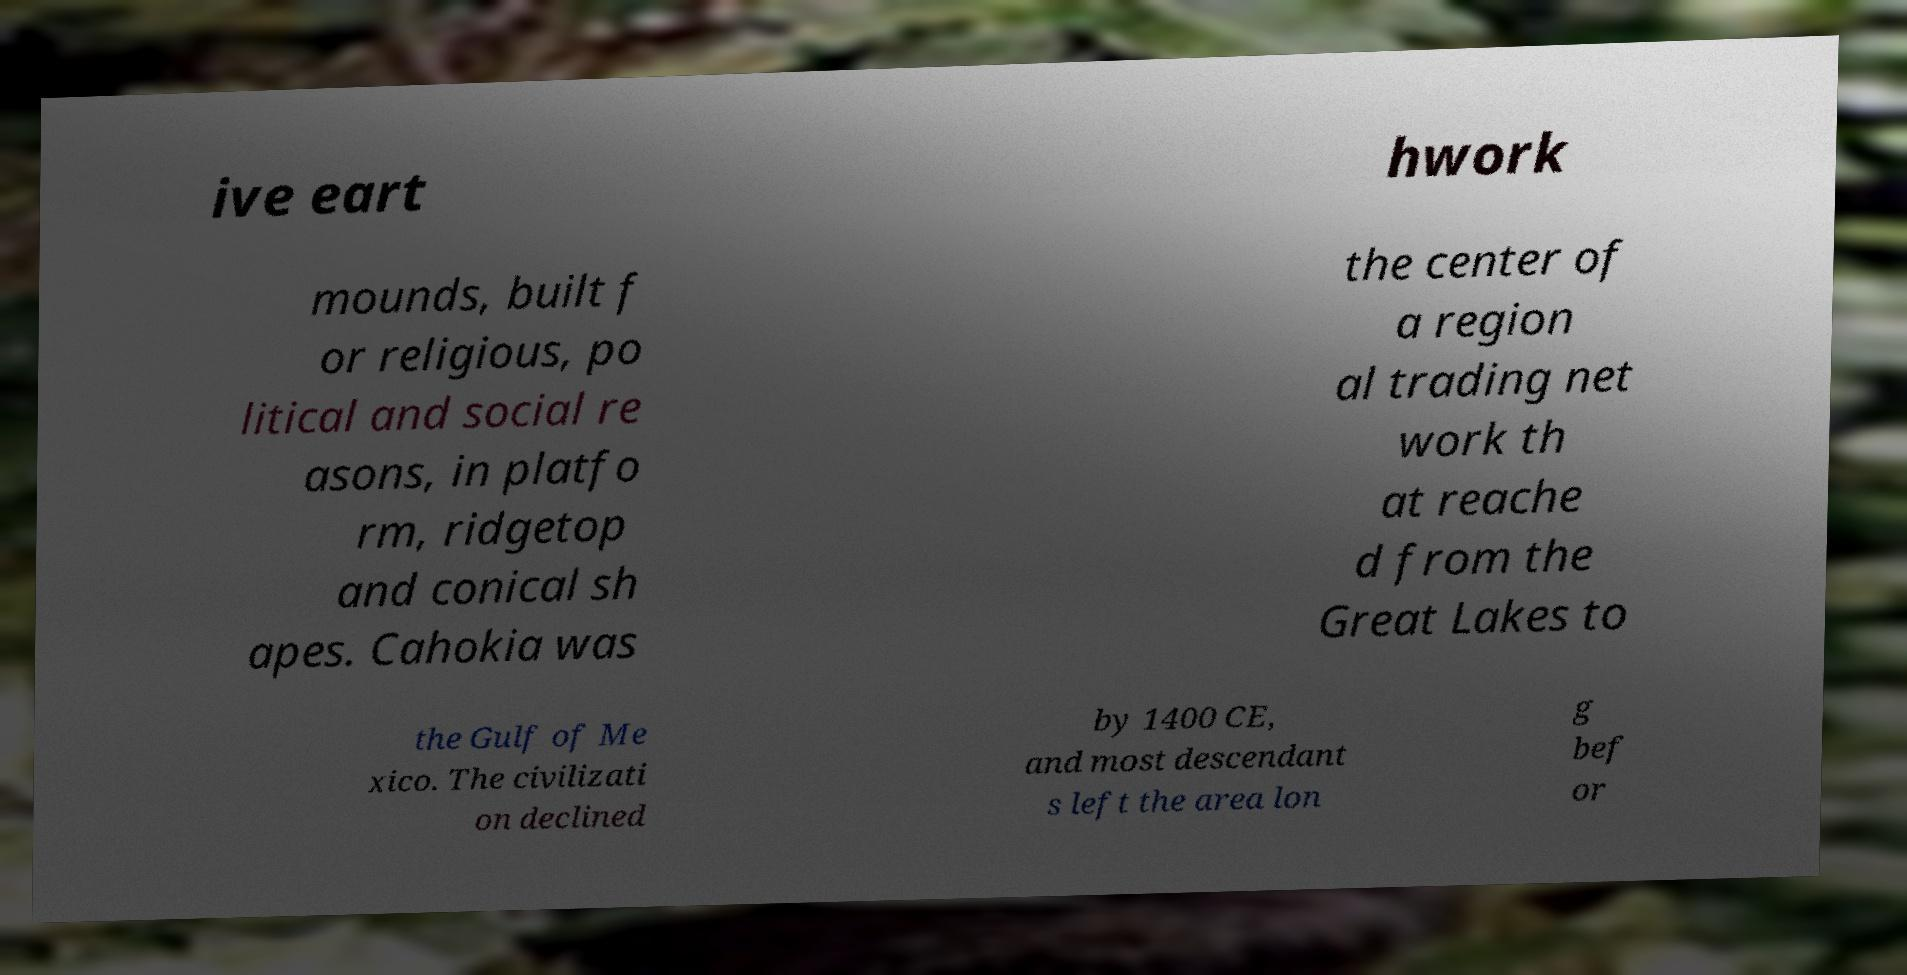I need the written content from this picture converted into text. Can you do that? ive eart hwork mounds, built f or religious, po litical and social re asons, in platfo rm, ridgetop and conical sh apes. Cahokia was the center of a region al trading net work th at reache d from the Great Lakes to the Gulf of Me xico. The civilizati on declined by 1400 CE, and most descendant s left the area lon g bef or 